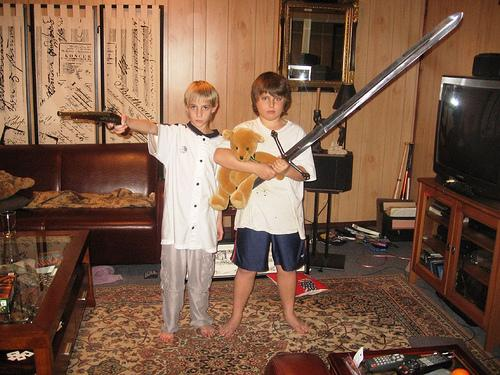What is the boy on the right holding? Please explain your reasoning. sword. The long and shiny weapon is in his hand. 